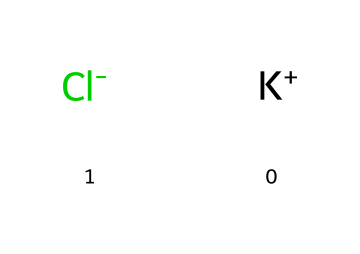What elements are present in this compound? The SMILES representation indicates two distinct components: potassium (K) and chlorine (Cl). These elements are explicitly shown in the structure.
Answer: potassium and chlorine How many atoms are in potassium chloride? By analyzing the SMILES string, there is one potassium ion (K+) and one chloride ion (Cl-), leading to a total of two atoms in the compound.
Answer: 2 What charge does chloride carry in this compound? The representation includes Cl- indicating that the chloride ion has a negative charge.
Answer: negative Is potassium chloride an electrolyte? Potassium chloride dissociates into K+ and Cl- ions when dissolved in water, making it an electrolyte.
Answer: yes What is the molecular formula for potassium chloride? From the components visible in the SMILES notation, the molecular formula can be deduced as KCl, comprising one potassium and one chloride.
Answer: KCl How does potassium chloride contribute to muscle function? Potassium ions are crucial for nerve signal transmission and muscle contraction, directly linking chloride as an accompanying ion that assists in maintaining electrical neutrality.
Answer: nerve signal transmission and muscle contraction 